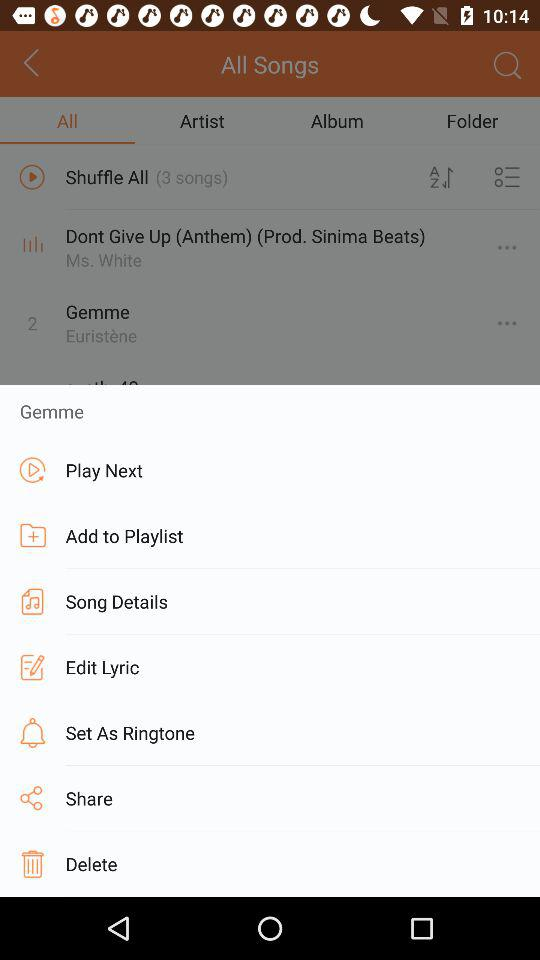How many more songs are in the Gemme album than the Dont Give Up (Anthem) (Prod. Sinima Beats) song?
Answer the question using a single word or phrase. 1 